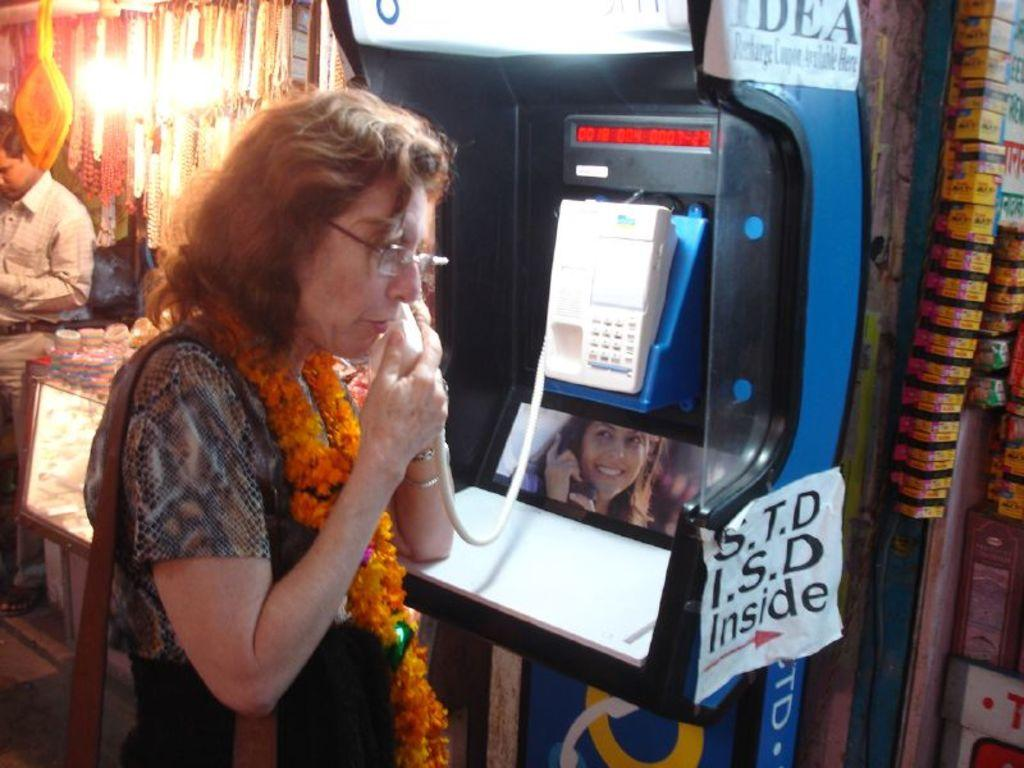Who is the main subject in the image? There is a lady in the image. What is the lady holding in the image? The lady is holding a bag. What is the lady doing in the image? The lady is talking in a telephone booth. What can be seen on either side of the telephone booth? There are stalls on either side of the telephone booth. Are there any other people present in the image? Yes, there is a person standing in the image. What is the angle of the telephone booth in the image? The angle of the telephone booth cannot be determined from the image, as it is a two-dimensional representation. Who is the expert in the image? There is no expert present in the image; it simply shows a lady talking in a telephone booth and a person standing nearby. 